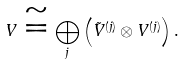<formula> <loc_0><loc_0><loc_500><loc_500>V \cong \bigoplus _ { j } \left ( \tilde { V } ^ { ( j ) } \otimes V ^ { ( j ) } \right ) .</formula> 